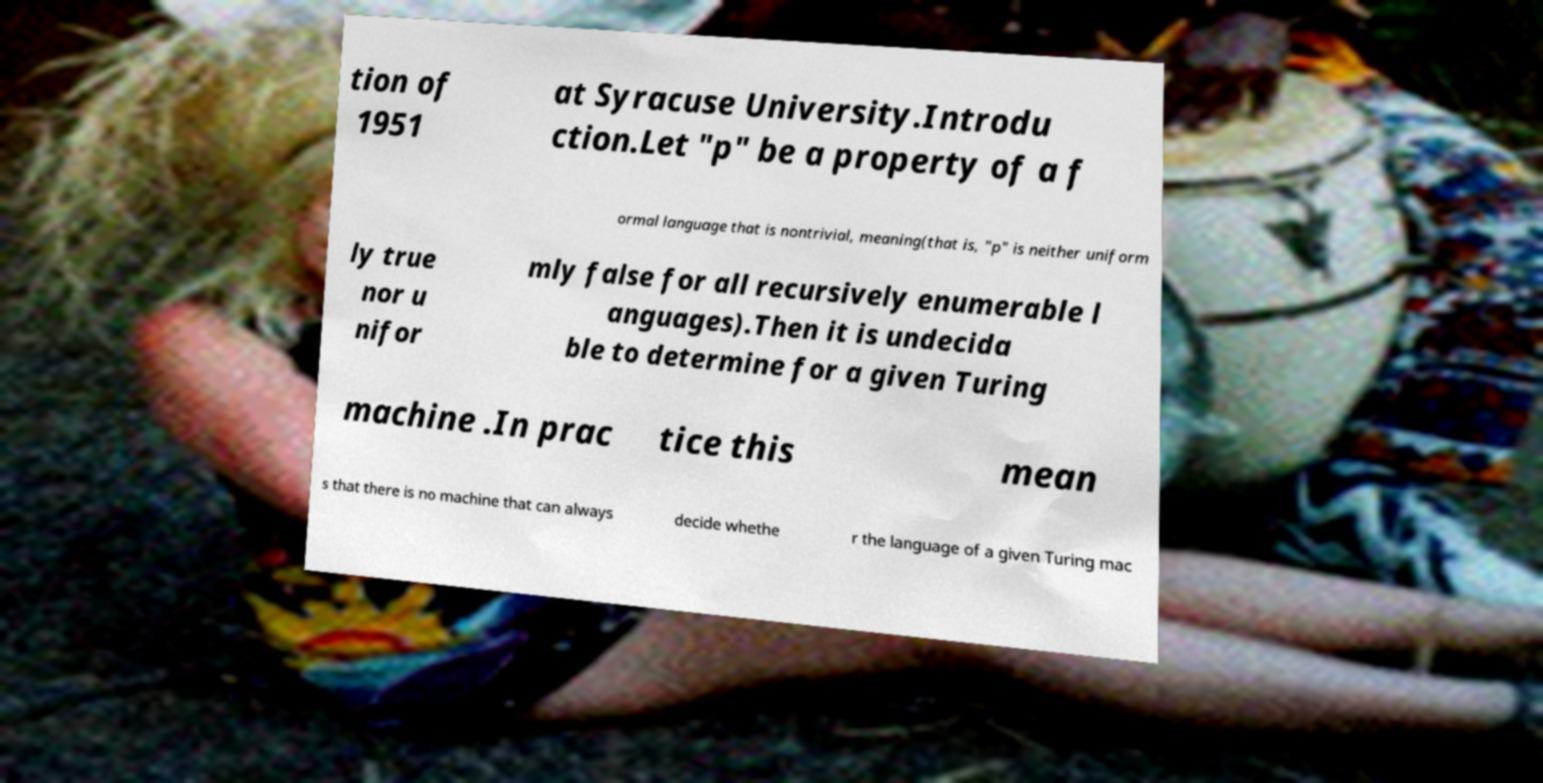Please read and relay the text visible in this image. What does it say? tion of 1951 at Syracuse University.Introdu ction.Let "p" be a property of a f ormal language that is nontrivial, meaning(that is, "p" is neither uniform ly true nor u nifor mly false for all recursively enumerable l anguages).Then it is undecida ble to determine for a given Turing machine .In prac tice this mean s that there is no machine that can always decide whethe r the language of a given Turing mac 